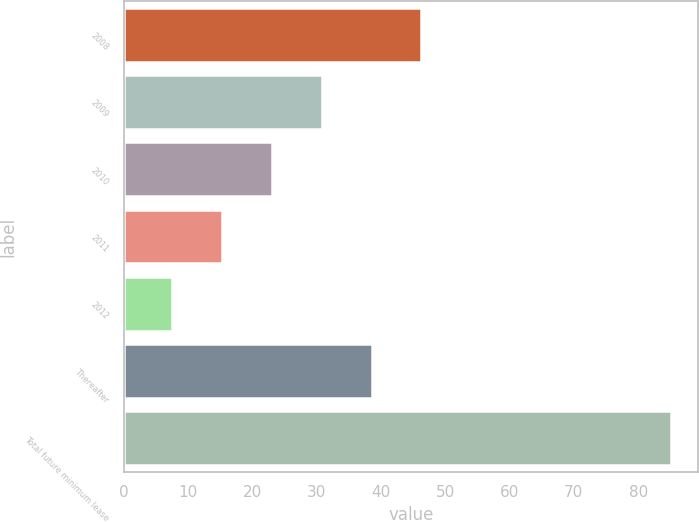Convert chart to OTSL. <chart><loc_0><loc_0><loc_500><loc_500><bar_chart><fcel>2008<fcel>2009<fcel>2010<fcel>2011<fcel>2012<fcel>Thereafter<fcel>Total future minimum lease<nl><fcel>46.3<fcel>30.78<fcel>23.02<fcel>15.26<fcel>7.5<fcel>38.54<fcel>85.1<nl></chart> 